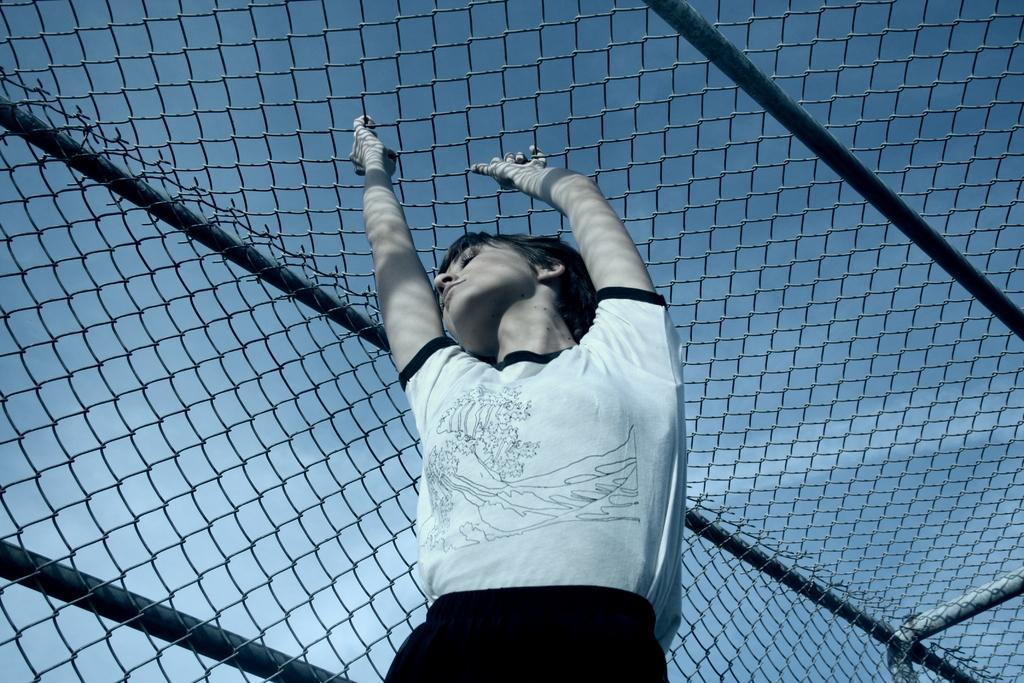Who is the main subject in the image? There is a woman in the image. What is the woman doing in the image? The woman is standing in the image. What object is the woman holding above her? The woman is holding a mesh above her. What type of truck can be seen parked next to the woman in the image? There is no truck present in the image; it only features a woman standing and holding a mesh above her. 